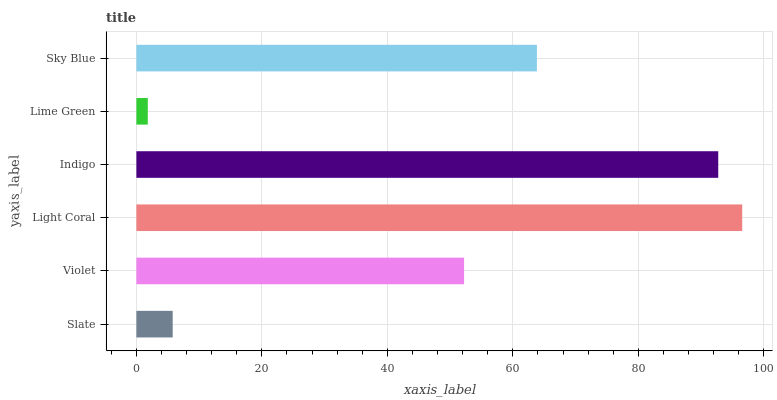Is Lime Green the minimum?
Answer yes or no. Yes. Is Light Coral the maximum?
Answer yes or no. Yes. Is Violet the minimum?
Answer yes or no. No. Is Violet the maximum?
Answer yes or no. No. Is Violet greater than Slate?
Answer yes or no. Yes. Is Slate less than Violet?
Answer yes or no. Yes. Is Slate greater than Violet?
Answer yes or no. No. Is Violet less than Slate?
Answer yes or no. No. Is Sky Blue the high median?
Answer yes or no. Yes. Is Violet the low median?
Answer yes or no. Yes. Is Light Coral the high median?
Answer yes or no. No. Is Lime Green the low median?
Answer yes or no. No. 